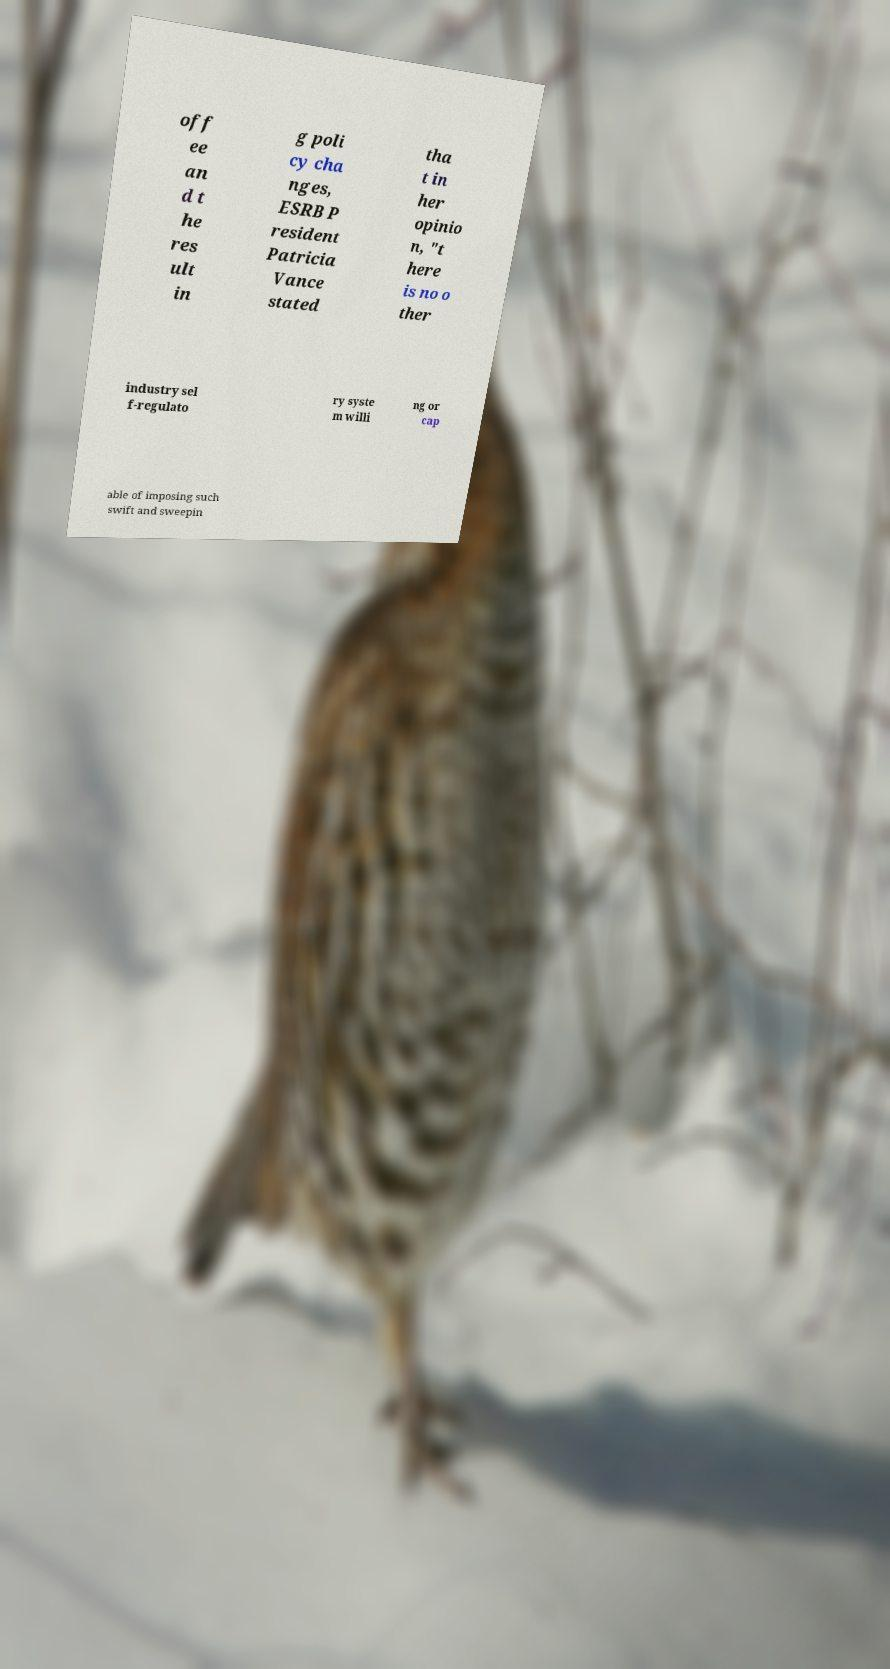Can you read and provide the text displayed in the image?This photo seems to have some interesting text. Can you extract and type it out for me? off ee an d t he res ult in g poli cy cha nges, ESRB P resident Patricia Vance stated tha t in her opinio n, "t here is no o ther industry sel f-regulato ry syste m willi ng or cap able of imposing such swift and sweepin 